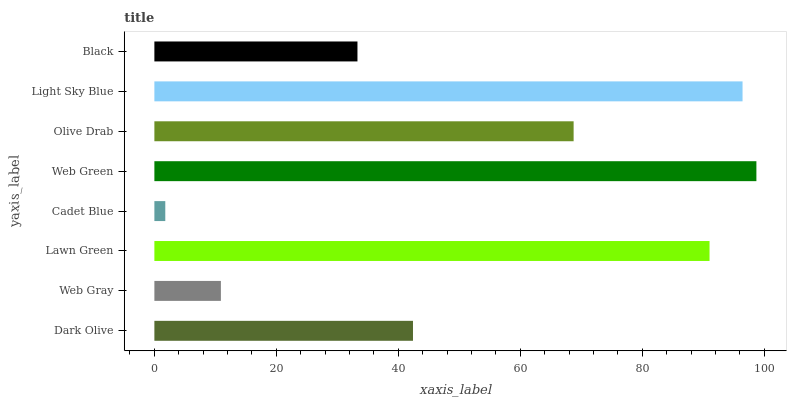Is Cadet Blue the minimum?
Answer yes or no. Yes. Is Web Green the maximum?
Answer yes or no. Yes. Is Web Gray the minimum?
Answer yes or no. No. Is Web Gray the maximum?
Answer yes or no. No. Is Dark Olive greater than Web Gray?
Answer yes or no. Yes. Is Web Gray less than Dark Olive?
Answer yes or no. Yes. Is Web Gray greater than Dark Olive?
Answer yes or no. No. Is Dark Olive less than Web Gray?
Answer yes or no. No. Is Olive Drab the high median?
Answer yes or no. Yes. Is Dark Olive the low median?
Answer yes or no. Yes. Is Web Gray the high median?
Answer yes or no. No. Is Cadet Blue the low median?
Answer yes or no. No. 